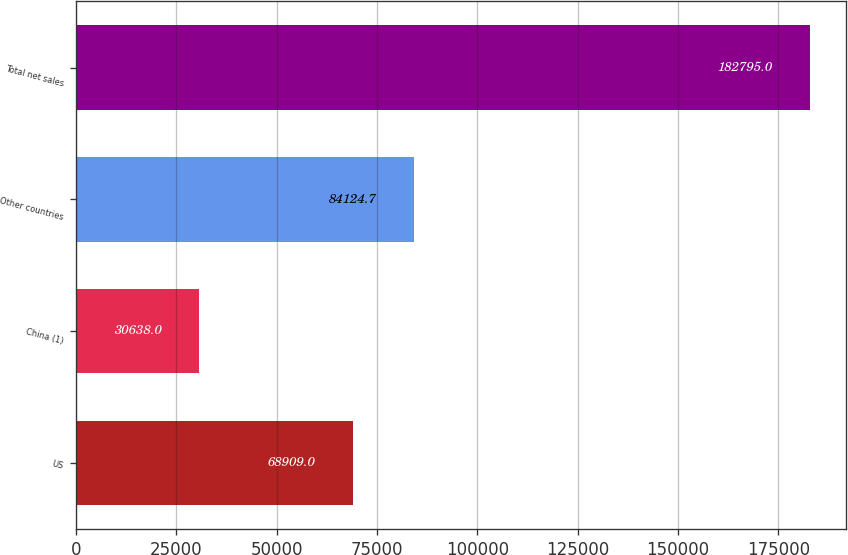<chart> <loc_0><loc_0><loc_500><loc_500><bar_chart><fcel>US<fcel>China (1)<fcel>Other countries<fcel>Total net sales<nl><fcel>68909<fcel>30638<fcel>84124.7<fcel>182795<nl></chart> 